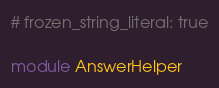Convert code to text. <code><loc_0><loc_0><loc_500><loc_500><_Ruby_># frozen_string_literal: true

module AnswerHelper</code> 